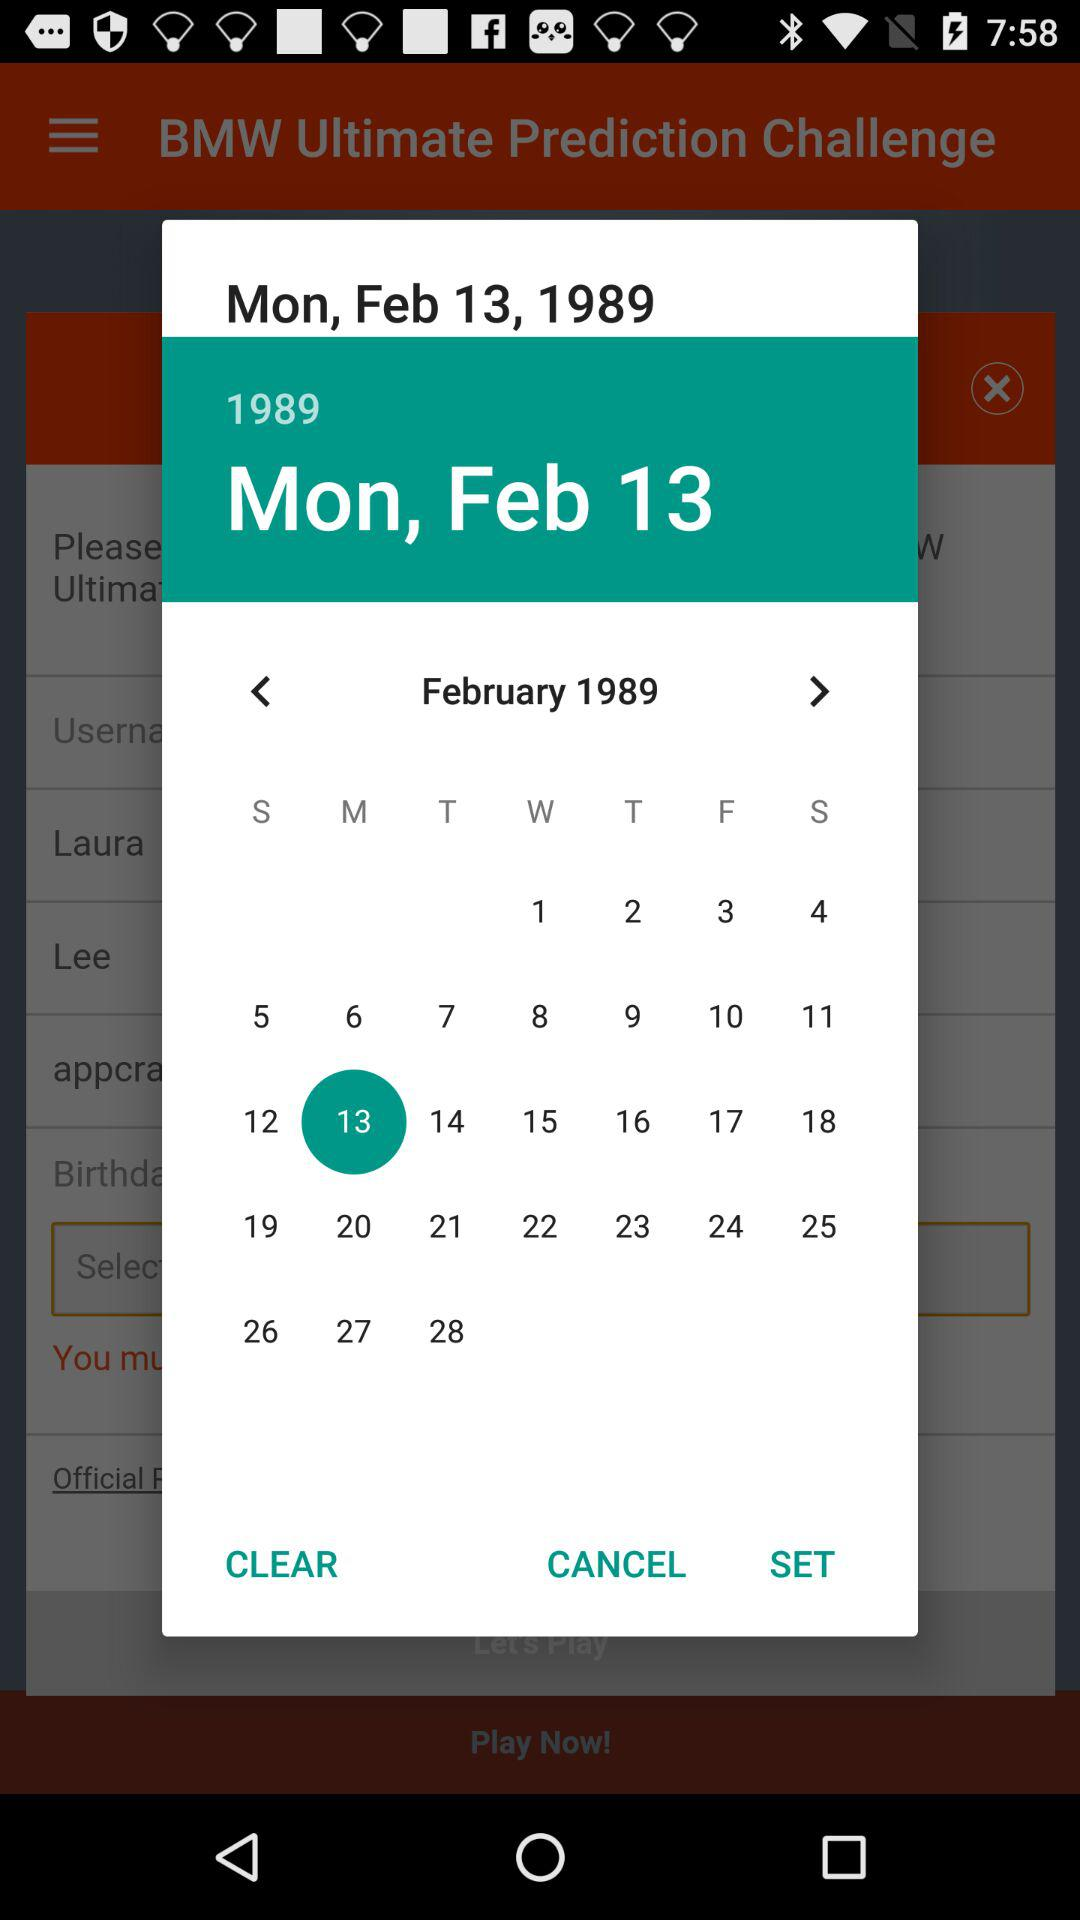What is the day of the selected date? The day is Monday. 